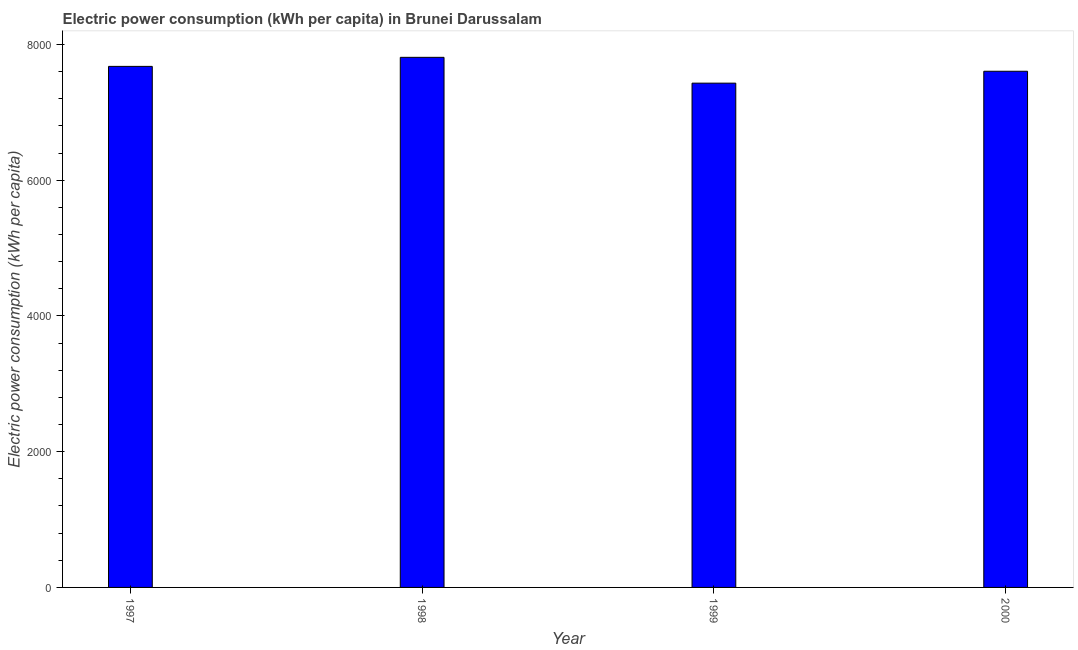Does the graph contain any zero values?
Make the answer very short. No. Does the graph contain grids?
Give a very brief answer. No. What is the title of the graph?
Your answer should be very brief. Electric power consumption (kWh per capita) in Brunei Darussalam. What is the label or title of the Y-axis?
Make the answer very short. Electric power consumption (kWh per capita). What is the electric power consumption in 2000?
Keep it short and to the point. 7605.41. Across all years, what is the maximum electric power consumption?
Provide a succinct answer. 7810.7. Across all years, what is the minimum electric power consumption?
Keep it short and to the point. 7430.24. In which year was the electric power consumption maximum?
Your response must be concise. 1998. What is the sum of the electric power consumption?
Provide a succinct answer. 3.05e+04. What is the difference between the electric power consumption in 1998 and 1999?
Your answer should be very brief. 380.46. What is the average electric power consumption per year?
Provide a succinct answer. 7630.9. What is the median electric power consumption?
Your response must be concise. 7641.34. What is the ratio of the electric power consumption in 1998 to that in 2000?
Provide a short and direct response. 1.03. What is the difference between the highest and the second highest electric power consumption?
Provide a succinct answer. 133.44. Is the sum of the electric power consumption in 1997 and 2000 greater than the maximum electric power consumption across all years?
Offer a very short reply. Yes. What is the difference between the highest and the lowest electric power consumption?
Offer a very short reply. 380.46. Are all the bars in the graph horizontal?
Your response must be concise. No. How many years are there in the graph?
Keep it short and to the point. 4. What is the Electric power consumption (kWh per capita) of 1997?
Provide a succinct answer. 7677.26. What is the Electric power consumption (kWh per capita) of 1998?
Offer a very short reply. 7810.7. What is the Electric power consumption (kWh per capita) of 1999?
Your answer should be compact. 7430.24. What is the Electric power consumption (kWh per capita) of 2000?
Your response must be concise. 7605.41. What is the difference between the Electric power consumption (kWh per capita) in 1997 and 1998?
Ensure brevity in your answer.  -133.44. What is the difference between the Electric power consumption (kWh per capita) in 1997 and 1999?
Your answer should be very brief. 247.02. What is the difference between the Electric power consumption (kWh per capita) in 1997 and 2000?
Provide a succinct answer. 71.84. What is the difference between the Electric power consumption (kWh per capita) in 1998 and 1999?
Provide a short and direct response. 380.46. What is the difference between the Electric power consumption (kWh per capita) in 1998 and 2000?
Provide a succinct answer. 205.29. What is the difference between the Electric power consumption (kWh per capita) in 1999 and 2000?
Keep it short and to the point. -175.18. What is the ratio of the Electric power consumption (kWh per capita) in 1997 to that in 1998?
Your answer should be very brief. 0.98. What is the ratio of the Electric power consumption (kWh per capita) in 1997 to that in 1999?
Your response must be concise. 1.03. What is the ratio of the Electric power consumption (kWh per capita) in 1997 to that in 2000?
Your answer should be very brief. 1.01. What is the ratio of the Electric power consumption (kWh per capita) in 1998 to that in 1999?
Give a very brief answer. 1.05. 